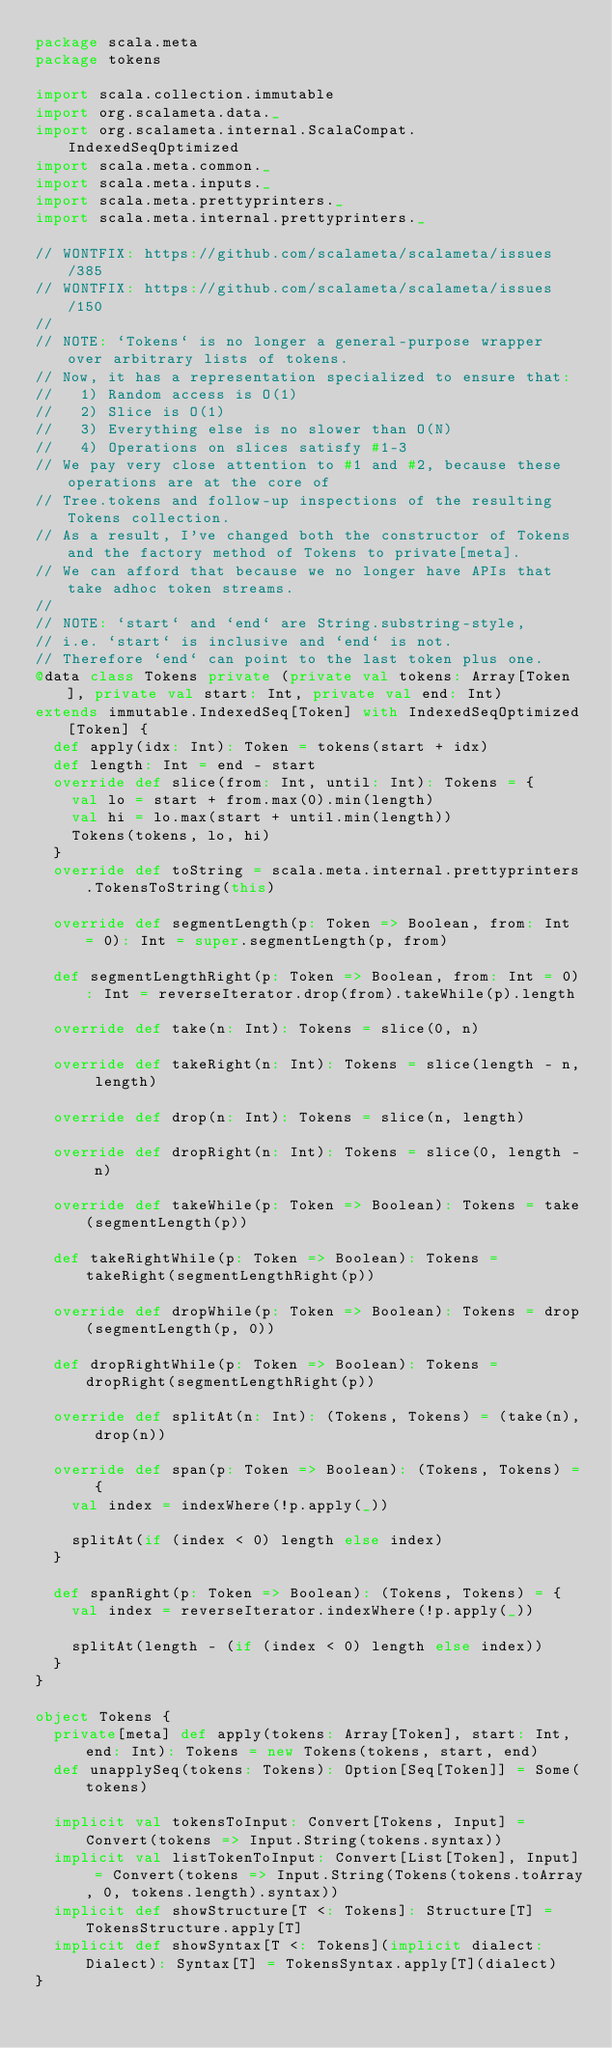<code> <loc_0><loc_0><loc_500><loc_500><_Scala_>package scala.meta
package tokens

import scala.collection.immutable
import org.scalameta.data._
import org.scalameta.internal.ScalaCompat.IndexedSeqOptimized
import scala.meta.common._
import scala.meta.inputs._
import scala.meta.prettyprinters._
import scala.meta.internal.prettyprinters._

// WONTFIX: https://github.com/scalameta/scalameta/issues/385
// WONTFIX: https://github.com/scalameta/scalameta/issues/150
//
// NOTE: `Tokens` is no longer a general-purpose wrapper over arbitrary lists of tokens.
// Now, it has a representation specialized to ensure that:
//   1) Random access is O(1)
//   2) Slice is O(1)
//   3) Everything else is no slower than O(N)
//   4) Operations on slices satisfy #1-3
// We pay very close attention to #1 and #2, because these operations are at the core of
// Tree.tokens and follow-up inspections of the resulting Tokens collection.
// As a result, I've changed both the constructor of Tokens and the factory method of Tokens to private[meta].
// We can afford that because we no longer have APIs that take adhoc token streams.
//
// NOTE: `start` and `end` are String.substring-style,
// i.e. `start` is inclusive and `end` is not.
// Therefore `end` can point to the last token plus one.
@data class Tokens private (private val tokens: Array[Token], private val start: Int, private val end: Int)
extends immutable.IndexedSeq[Token] with IndexedSeqOptimized[Token] {
  def apply(idx: Int): Token = tokens(start + idx)
  def length: Int = end - start
  override def slice(from: Int, until: Int): Tokens = {
    val lo = start + from.max(0).min(length)
    val hi = lo.max(start + until.min(length))
    Tokens(tokens, lo, hi)
  }
  override def toString = scala.meta.internal.prettyprinters.TokensToString(this)

  override def segmentLength(p: Token => Boolean, from: Int = 0): Int = super.segmentLength(p, from)

  def segmentLengthRight(p: Token => Boolean, from: Int = 0): Int = reverseIterator.drop(from).takeWhile(p).length

  override def take(n: Int): Tokens = slice(0, n)

  override def takeRight(n: Int): Tokens = slice(length - n, length)

  override def drop(n: Int): Tokens = slice(n, length)

  override def dropRight(n: Int): Tokens = slice(0, length - n)

  override def takeWhile(p: Token => Boolean): Tokens = take(segmentLength(p))

  def takeRightWhile(p: Token => Boolean): Tokens = takeRight(segmentLengthRight(p))

  override def dropWhile(p: Token => Boolean): Tokens = drop(segmentLength(p, 0))

  def dropRightWhile(p: Token => Boolean): Tokens = dropRight(segmentLengthRight(p))

  override def splitAt(n: Int): (Tokens, Tokens) = (take(n), drop(n))

  override def span(p: Token => Boolean): (Tokens, Tokens) = {
    val index = indexWhere(!p.apply(_))

    splitAt(if (index < 0) length else index)
  }

  def spanRight(p: Token => Boolean): (Tokens, Tokens) = {
    val index = reverseIterator.indexWhere(!p.apply(_))

    splitAt(length - (if (index < 0) length else index))
  }
}

object Tokens {
  private[meta] def apply(tokens: Array[Token], start: Int, end: Int): Tokens = new Tokens(tokens, start, end)
  def unapplySeq(tokens: Tokens): Option[Seq[Token]] = Some(tokens)

  implicit val tokensToInput: Convert[Tokens, Input] = Convert(tokens => Input.String(tokens.syntax))
  implicit val listTokenToInput: Convert[List[Token], Input] = Convert(tokens => Input.String(Tokens(tokens.toArray, 0, tokens.length).syntax))
  implicit def showStructure[T <: Tokens]: Structure[T] = TokensStructure.apply[T]
  implicit def showSyntax[T <: Tokens](implicit dialect: Dialect): Syntax[T] = TokensSyntax.apply[T](dialect)
}
</code> 